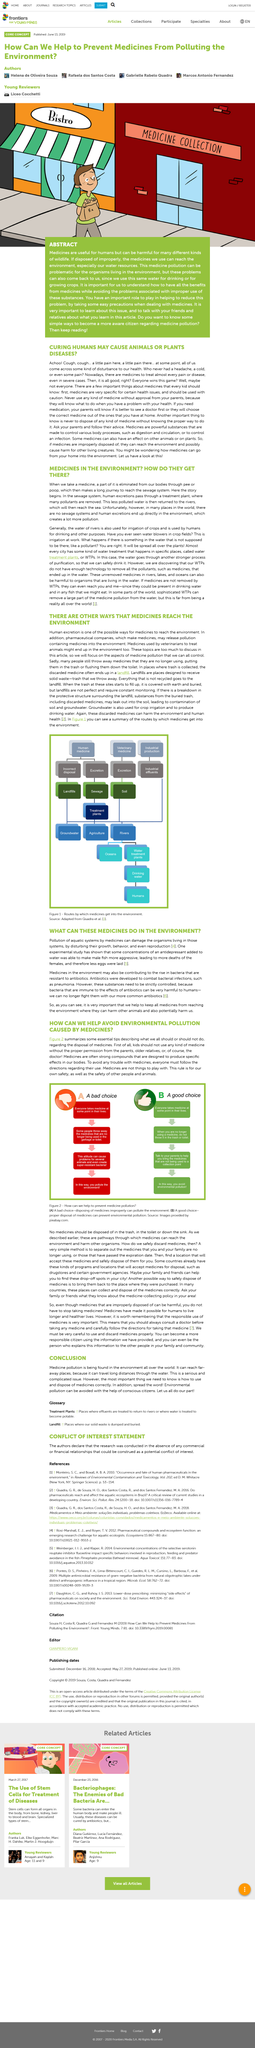Point out several critical features in this image. The elimination of a part of medicine from the body occurs through urination or defecation. The issue of medical pollution is a significant problem because it can spread over long distances through water, posing a significant risk to human health and the environment. It is imperative that children should not carry medicine without proper authorization, as this poses a significant risk to their health and safety. Yes, humans are at risk from medicines in the environment, as bacteria are becoming increasingly resistant to antibiotics. This article is titled 'Conclusion' and it relates to the topic of Medicine Pollution, which is a growing concern worldwide due to the increasing amount of pollution found in the environment. 